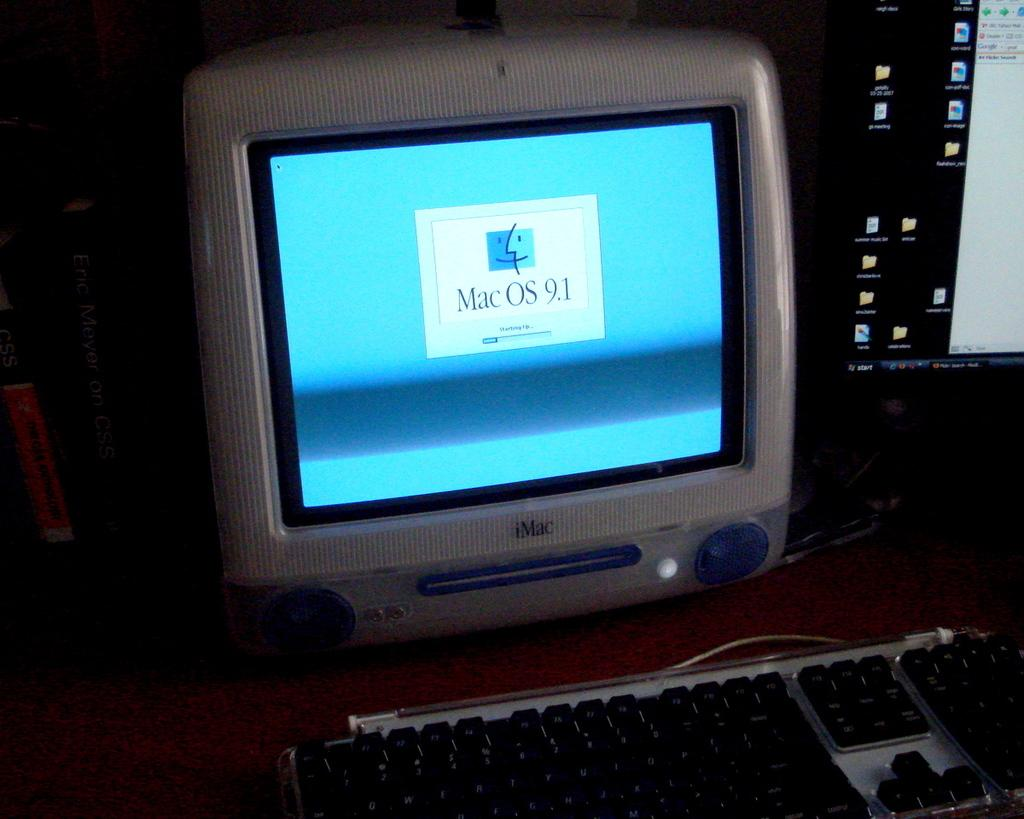Provide a one-sentence caption for the provided image. Mac OS 9.1 can be used on this computer. 